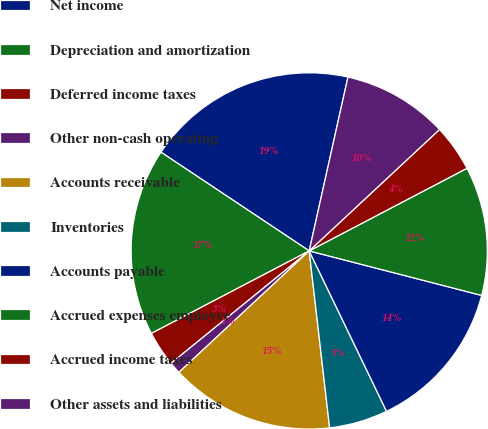Convert chart. <chart><loc_0><loc_0><loc_500><loc_500><pie_chart><fcel>Net income<fcel>Depreciation and amortization<fcel>Deferred income taxes<fcel>Other non-cash operating<fcel>Accounts receivable<fcel>Inventories<fcel>Accounts payable<fcel>Accrued expenses employee<fcel>Accrued income taxes<fcel>Other assets and liabilities<nl><fcel>19.14%<fcel>17.02%<fcel>3.2%<fcel>1.07%<fcel>14.89%<fcel>5.32%<fcel>13.83%<fcel>11.7%<fcel>4.26%<fcel>9.57%<nl></chart> 